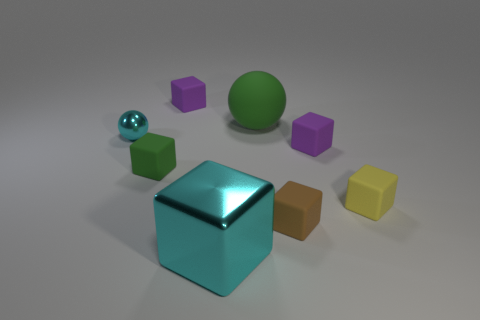Is the number of cyan objects less than the number of metallic balls?
Keep it short and to the point. No. Does the big thing behind the brown block have the same shape as the large object that is in front of the big rubber object?
Give a very brief answer. No. How many things are either cyan metal cubes or large balls?
Give a very brief answer. 2. There is a shiny sphere that is the same size as the yellow block; what color is it?
Your answer should be compact. Cyan. There is a purple thing on the right side of the tiny brown matte object; how many brown cubes are behind it?
Offer a very short reply. 0. How many objects are both left of the rubber ball and behind the brown cube?
Provide a short and direct response. 3. How many objects are either purple matte blocks that are on the left side of the brown matte block or matte things behind the small brown block?
Make the answer very short. 5. What number of other things are the same size as the yellow rubber object?
Offer a very short reply. 5. What shape is the large object in front of the tiny purple rubber object to the right of the brown object?
Your answer should be very brief. Cube. There is a metal ball that is on the left side of the brown thing; is it the same color as the matte cube that is behind the green ball?
Your answer should be very brief. No. 